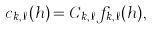Convert formula to latex. <formula><loc_0><loc_0><loc_500><loc_500>c _ { k , \ell } ( h ) = C _ { k , \ell } f _ { k , \ell } ( h ) ,</formula> 